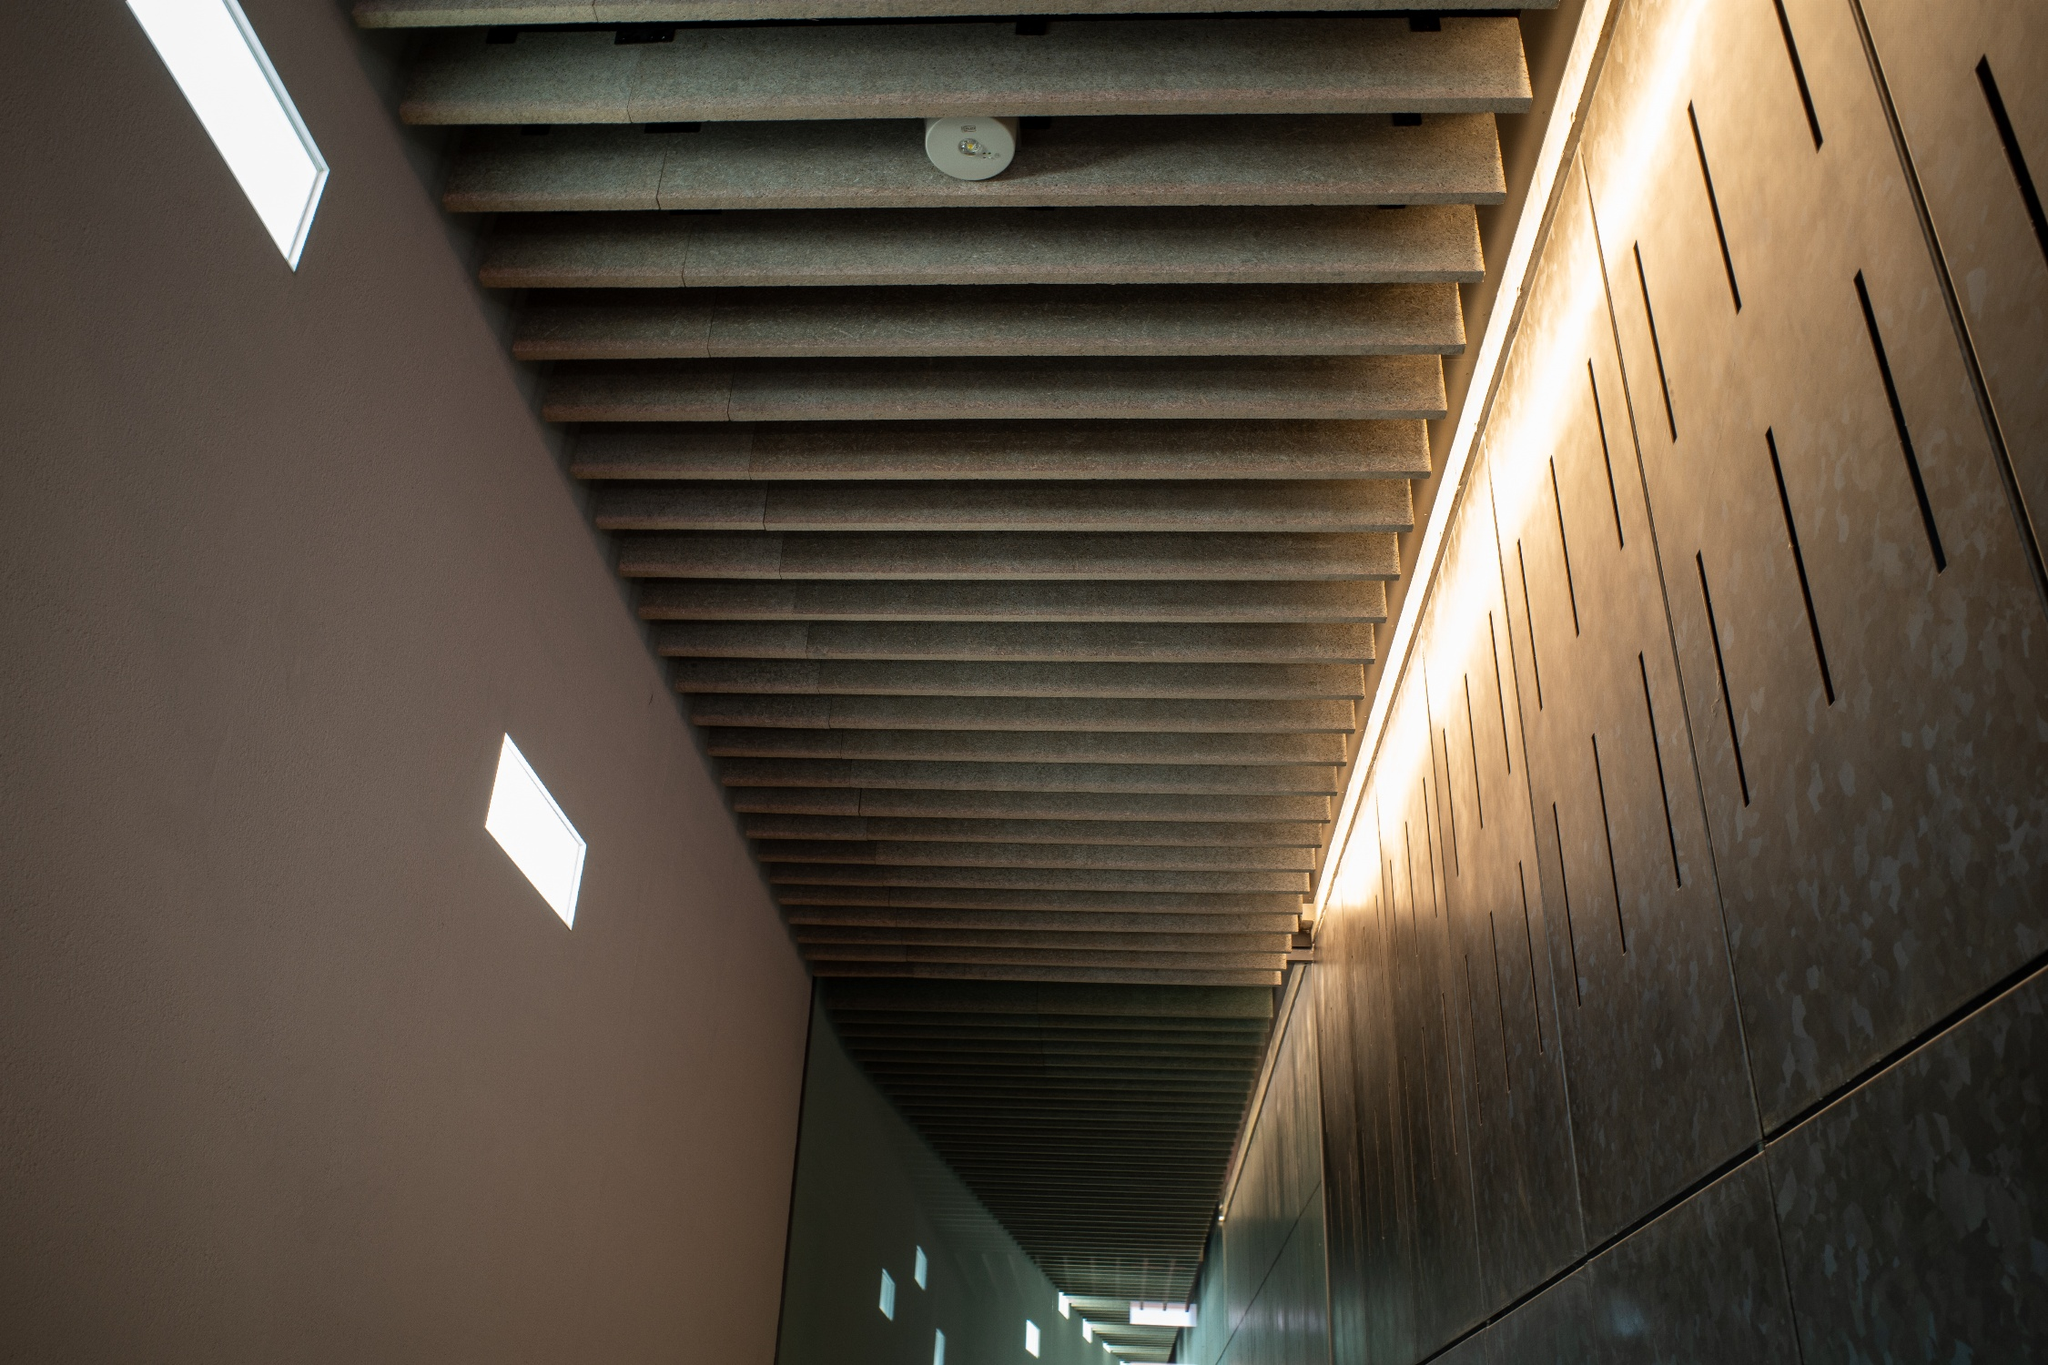What could be the function of this hallway in a public building? This hallway could serve as a transitional space in a modern art museum. Its minimalist design and clean lines direct visitors' attention toward the artwork on display in adjoining rooms. The serene ambiance created by the natural light penetrating through the small, strategically placed windows, combined with the soft reflections from the polished stone floor, prepares visitors for an immersive and contemplative experience with the exhibits. 